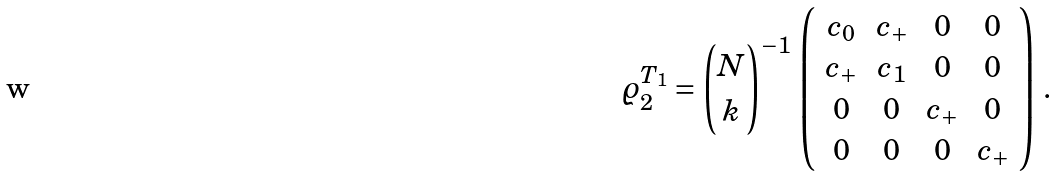<formula> <loc_0><loc_0><loc_500><loc_500>\varrho _ { 2 } ^ { T _ { 1 } } = { N \choose k } ^ { - 1 } \, \left ( \begin{array} { c c c c } c _ { 0 } & c _ { + } & 0 & 0 \\ c _ { + } & c _ { 1 } & 0 & 0 \\ 0 & 0 & c _ { + } & 0 \\ 0 & 0 & 0 & c _ { + } \end{array} \right ) \, .</formula> 